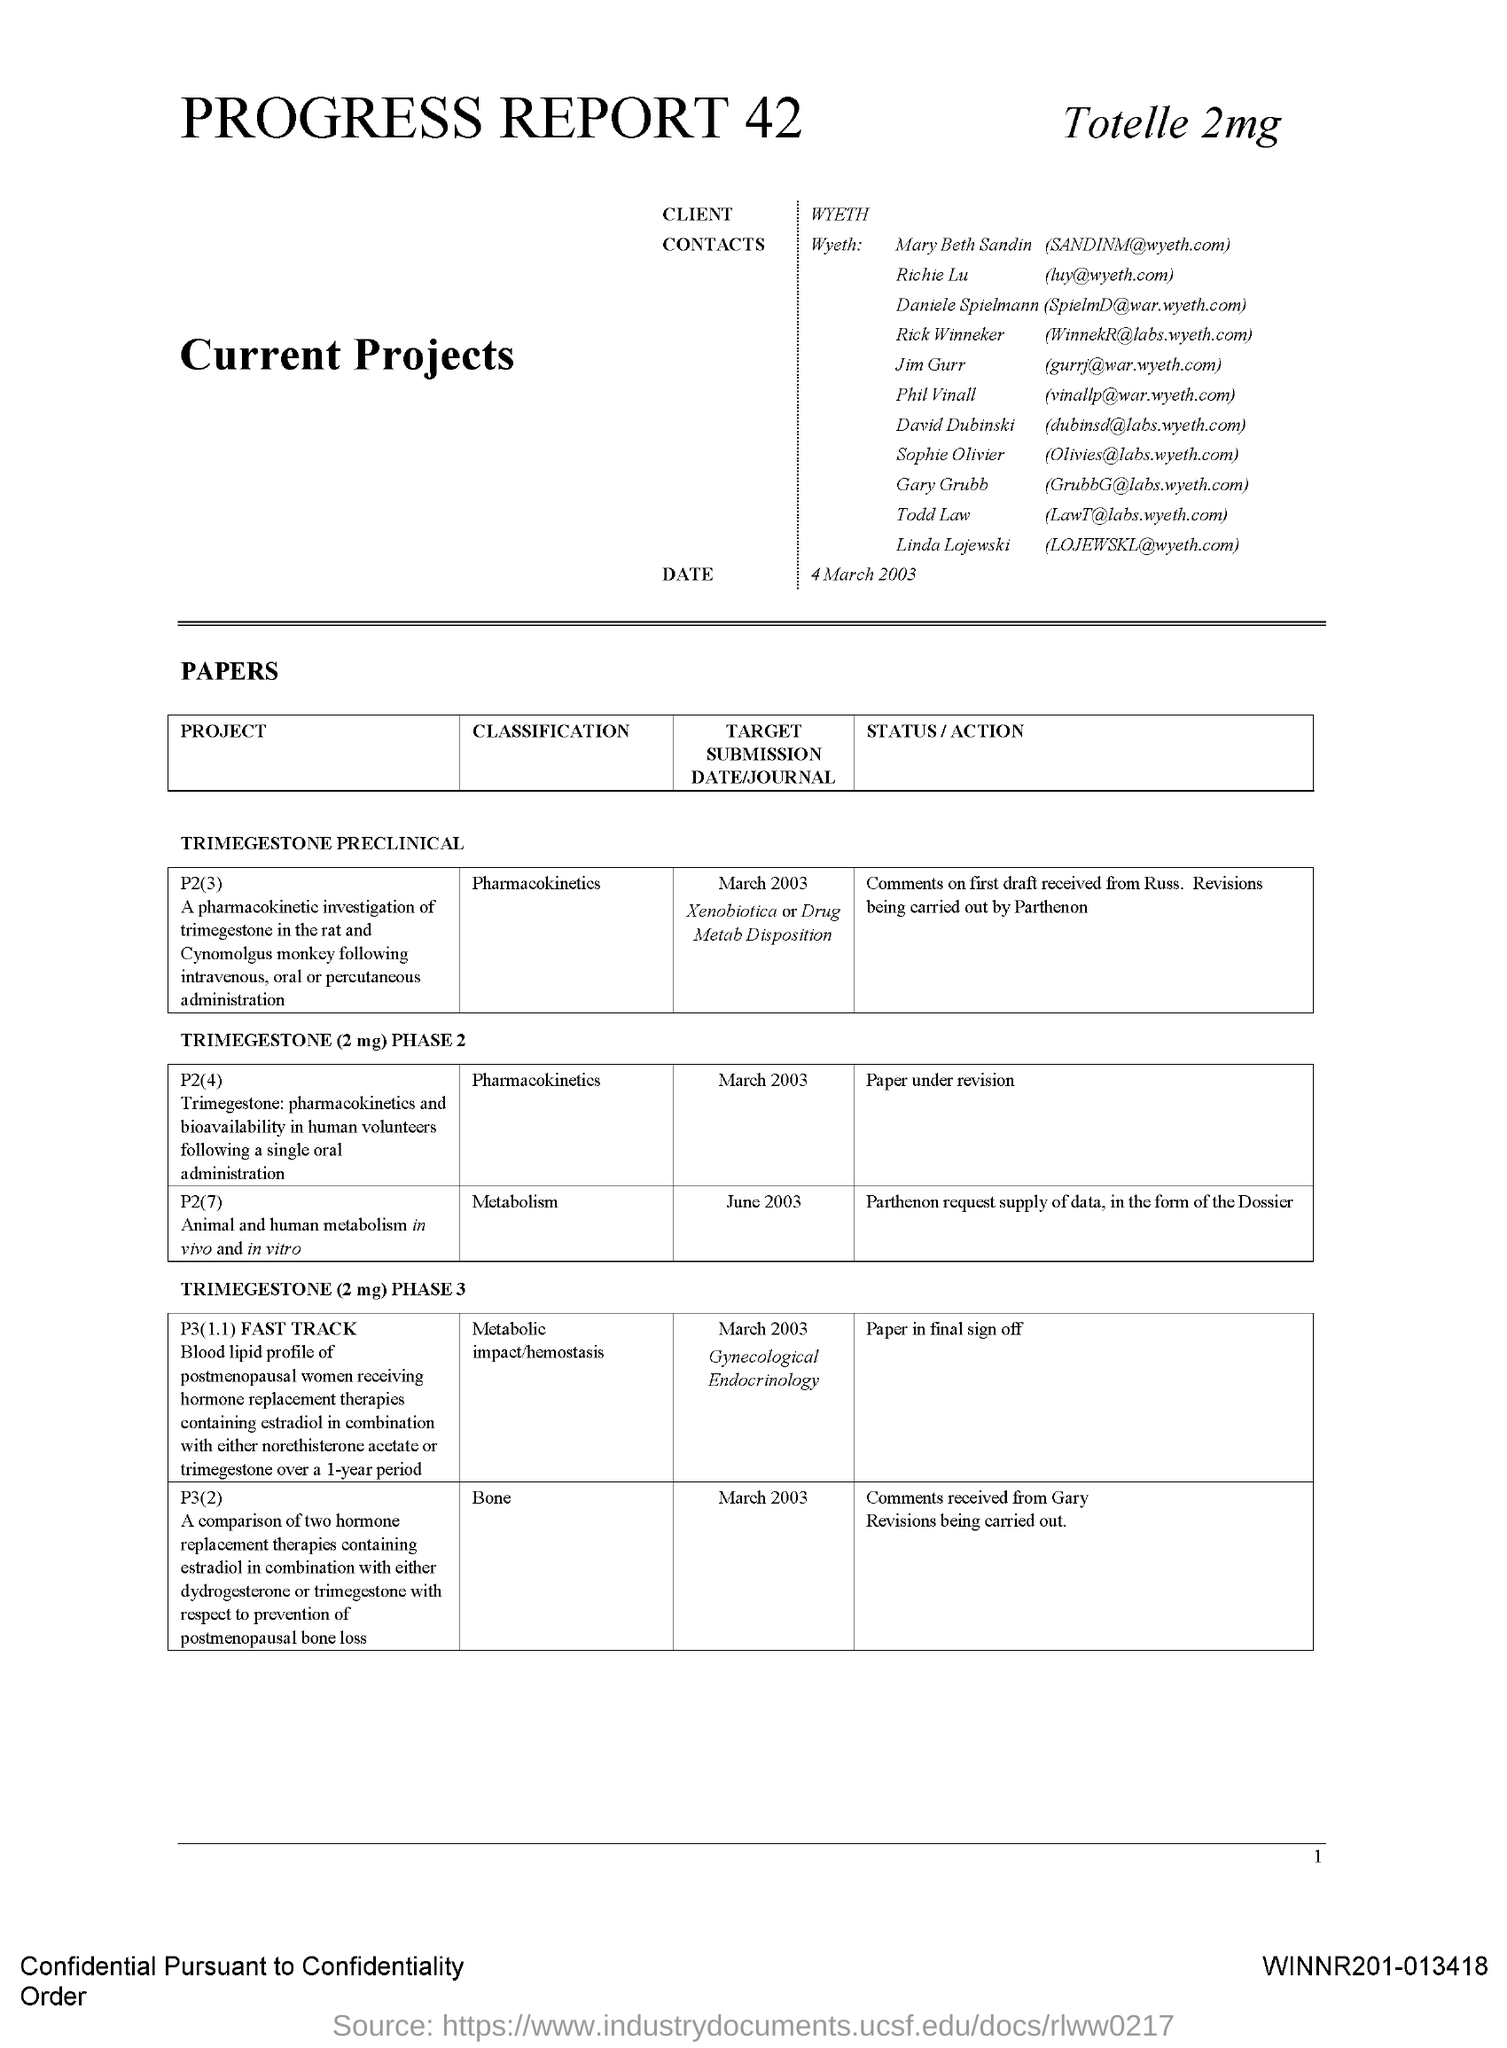What is the client name mentioned in this document?
Offer a very short reply. Wyeth. 